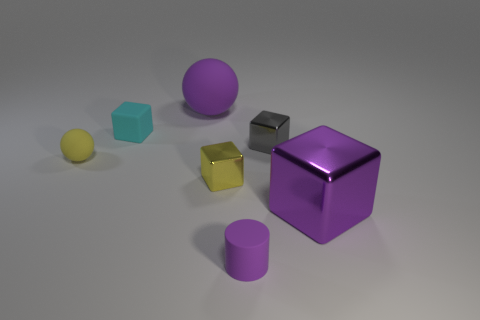Add 1 matte cubes. How many objects exist? 8 Subtract all purple metallic blocks. How many blocks are left? 3 Subtract all gray cubes. Subtract all cyan spheres. How many cubes are left? 3 Subtract all yellow cubes. How many blue cylinders are left? 0 Subtract all big green matte blocks. Subtract all small cylinders. How many objects are left? 6 Add 1 cylinders. How many cylinders are left? 2 Add 6 small red metallic cubes. How many small red metallic cubes exist? 6 Subtract all yellow spheres. How many spheres are left? 1 Subtract 1 purple cylinders. How many objects are left? 6 Subtract all spheres. How many objects are left? 5 